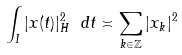Convert formula to latex. <formula><loc_0><loc_0><loc_500><loc_500>\int _ { I } | x ( t ) | _ { H } ^ { 2 } \ d t \asymp \sum _ { k \in \mathbb { Z } } | x _ { k } | ^ { 2 }</formula> 